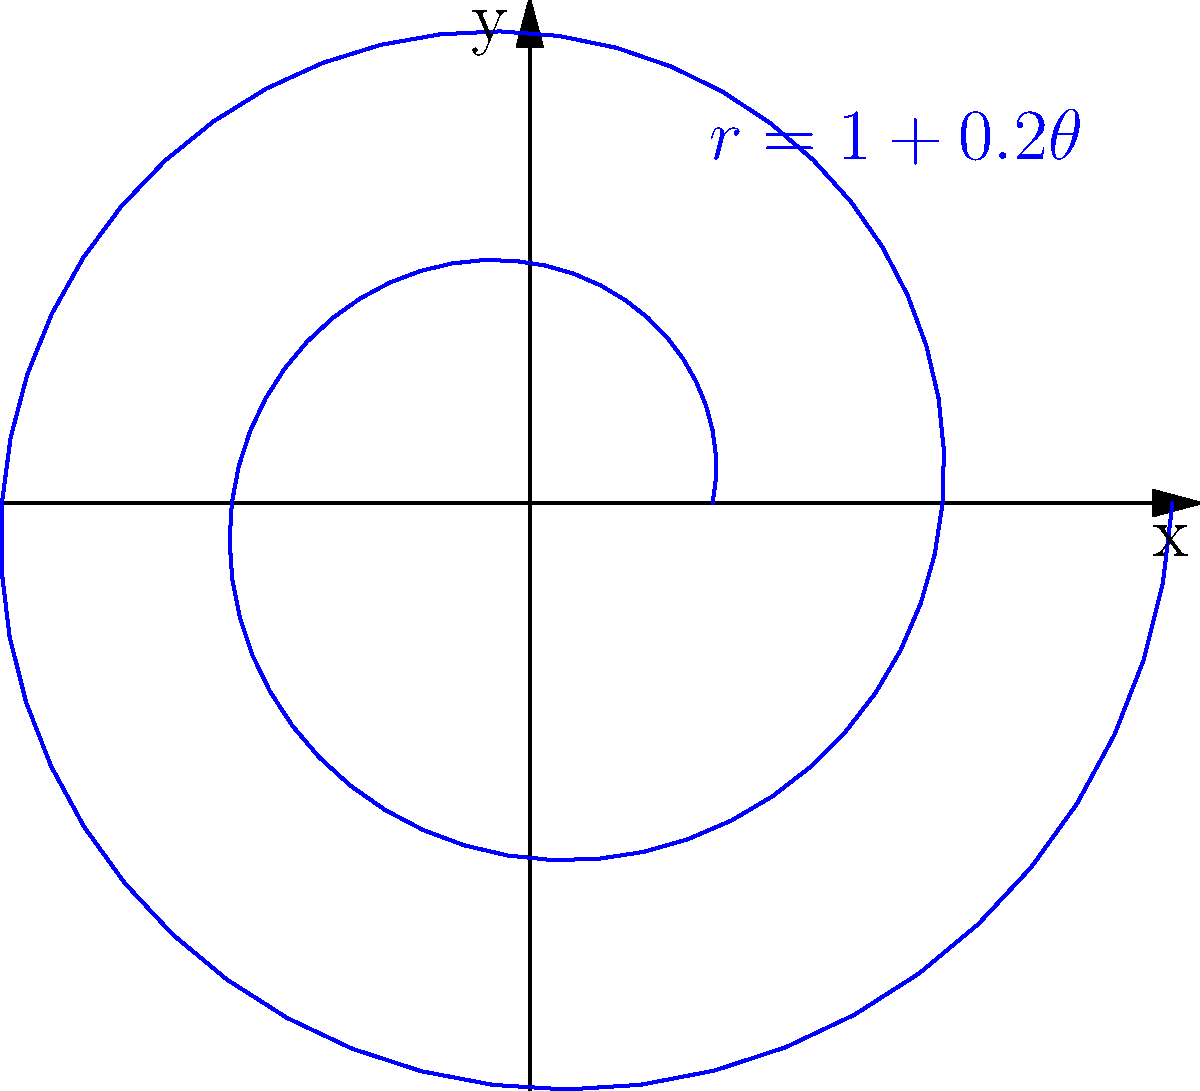In designing a spiral staircase for a futuristic building, you want to incorporate a variable thread width that increases as the staircase ascends. The polar function $r = 1 + 0.2\theta$ (where $r$ is in meters and $\theta$ is in radians) describes the centerline of the staircase. What is the total length of the centerline for two complete revolutions of the staircase? To find the length of the spiral staircase's centerline, we need to use the arc length formula for polar functions:

1) The arc length formula for polar functions is:
   $$L = \int_a^b \sqrt{r^2 + \left(\frac{dr}{d\theta}\right)^2} d\theta$$

2) For our function $r = 1 + 0.2\theta$:
   $r = 1 + 0.2\theta$
   $\frac{dr}{d\theta} = 0.2$

3) Substituting into the formula:
   $$L = \int_0^{4\pi} \sqrt{(1 + 0.2\theta)^2 + (0.2)^2} d\theta$$

4) Simplify under the square root:
   $$L = \int_0^{4\pi} \sqrt{1 + 0.4\theta + 0.04\theta^2 + 0.04} d\theta$$
   $$L = \int_0^{4\pi} \sqrt{1.04 + 0.4\theta + 0.04\theta^2} d\theta$$

5) This integral doesn't have a simple analytical solution, so we need to use numerical integration methods.

6) Using a numerical integration tool, we find:
   $$L \approx 28.32 \text{ meters}$$

Therefore, the total length of the centerline for two complete revolutions is approximately 28.32 meters.
Answer: 28.32 meters 